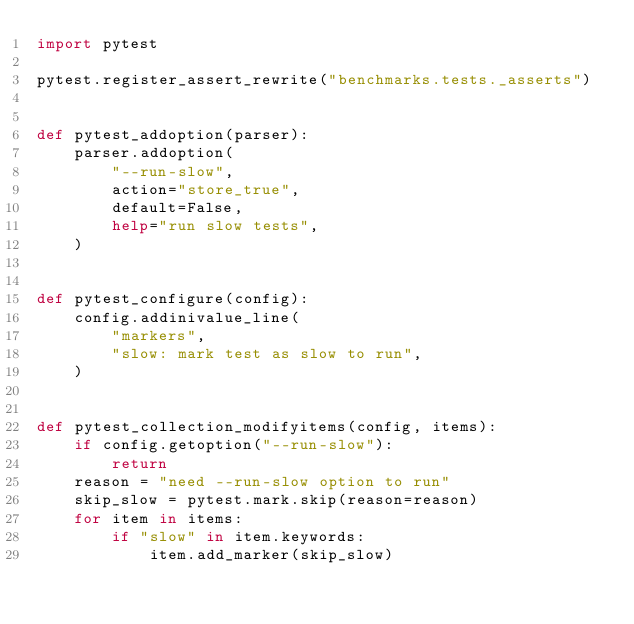<code> <loc_0><loc_0><loc_500><loc_500><_Python_>import pytest

pytest.register_assert_rewrite("benchmarks.tests._asserts")


def pytest_addoption(parser):
    parser.addoption(
        "--run-slow",
        action="store_true",
        default=False,
        help="run slow tests",
    )


def pytest_configure(config):
    config.addinivalue_line(
        "markers",
        "slow: mark test as slow to run",
    )


def pytest_collection_modifyitems(config, items):
    if config.getoption("--run-slow"):
        return
    reason = "need --run-slow option to run"
    skip_slow = pytest.mark.skip(reason=reason)
    for item in items:
        if "slow" in item.keywords:
            item.add_marker(skip_slow)
</code> 